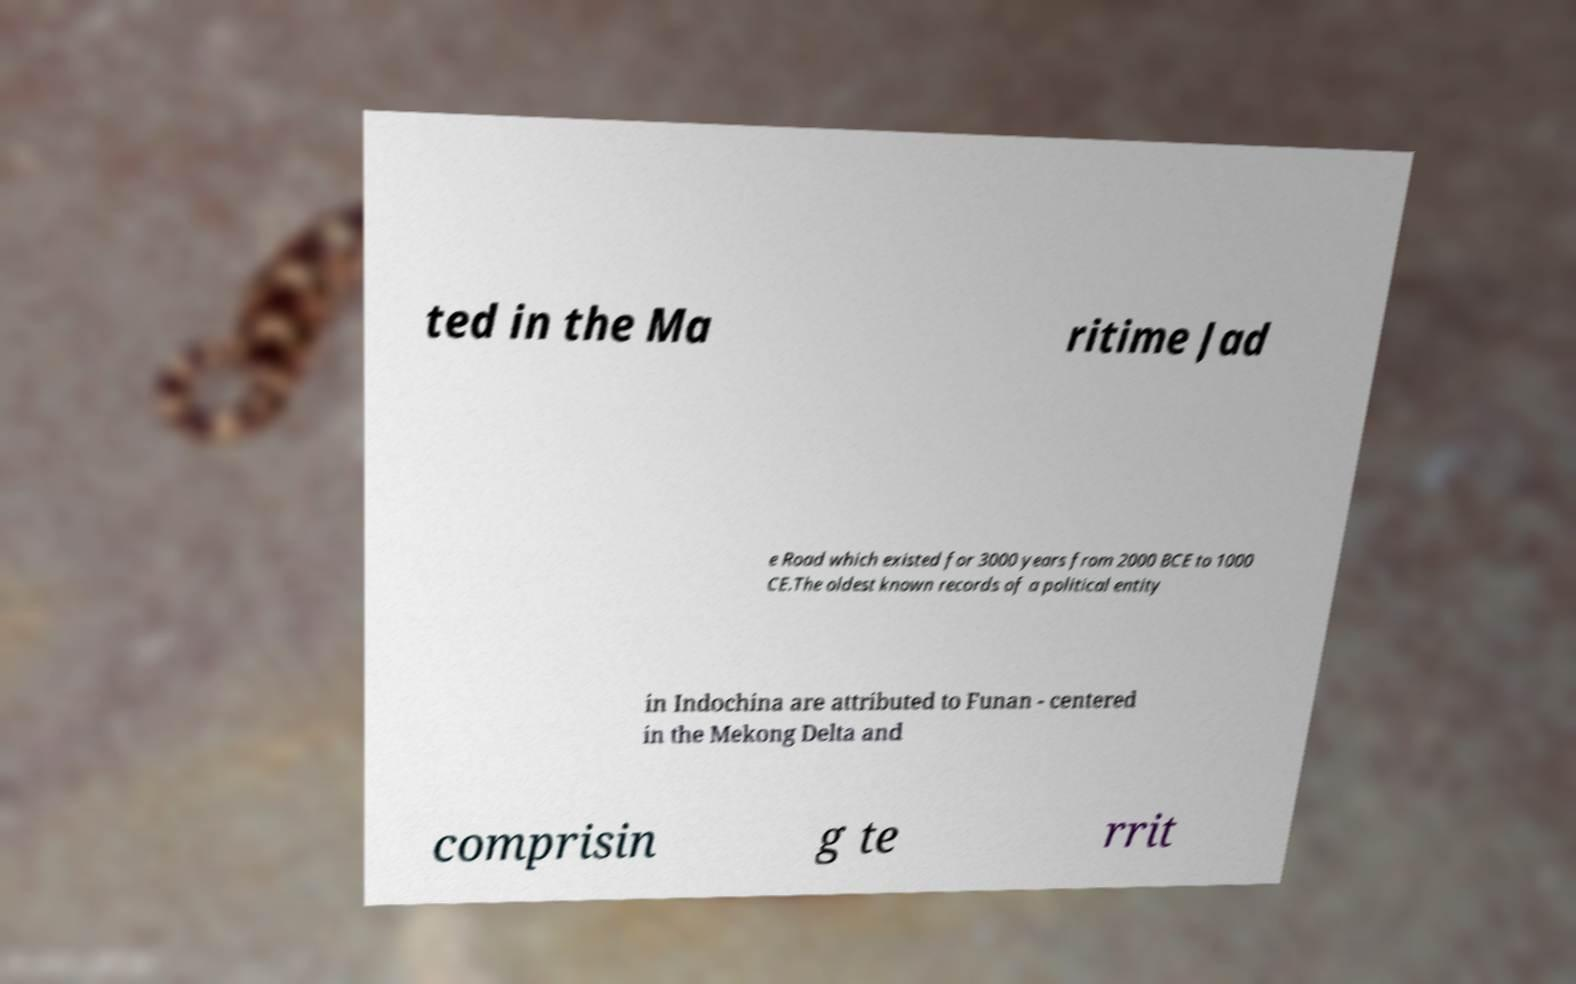Please read and relay the text visible in this image. What does it say? ted in the Ma ritime Jad e Road which existed for 3000 years from 2000 BCE to 1000 CE.The oldest known records of a political entity in Indochina are attributed to Funan - centered in the Mekong Delta and comprisin g te rrit 